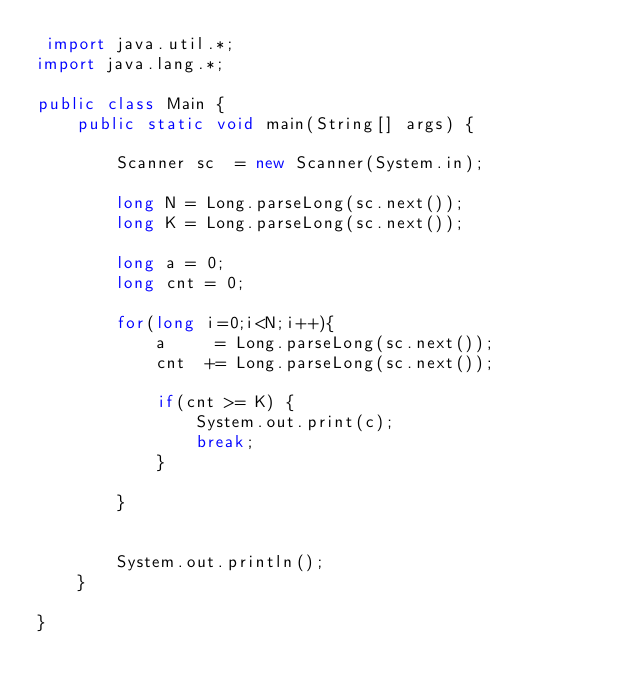Convert code to text. <code><loc_0><loc_0><loc_500><loc_500><_Java_> import java.util.*;
import java.lang.*;
 
public class Main {
    public static void main(String[] args) {

        Scanner sc  = new Scanner(System.in);

        long N = Long.parseLong(sc.next());
        long K = Long.parseLong(sc.next());
        
        long a = 0;
        long cnt = 0;

        for(long i=0;i<N;i++){
            a     = Long.parseLong(sc.next());
            cnt  += Long.parseLong(sc.next());
            
            if(cnt >= K) {
                System.out.print(c);
                break;   
            }
            
        }


        System.out.println();
    }

}</code> 